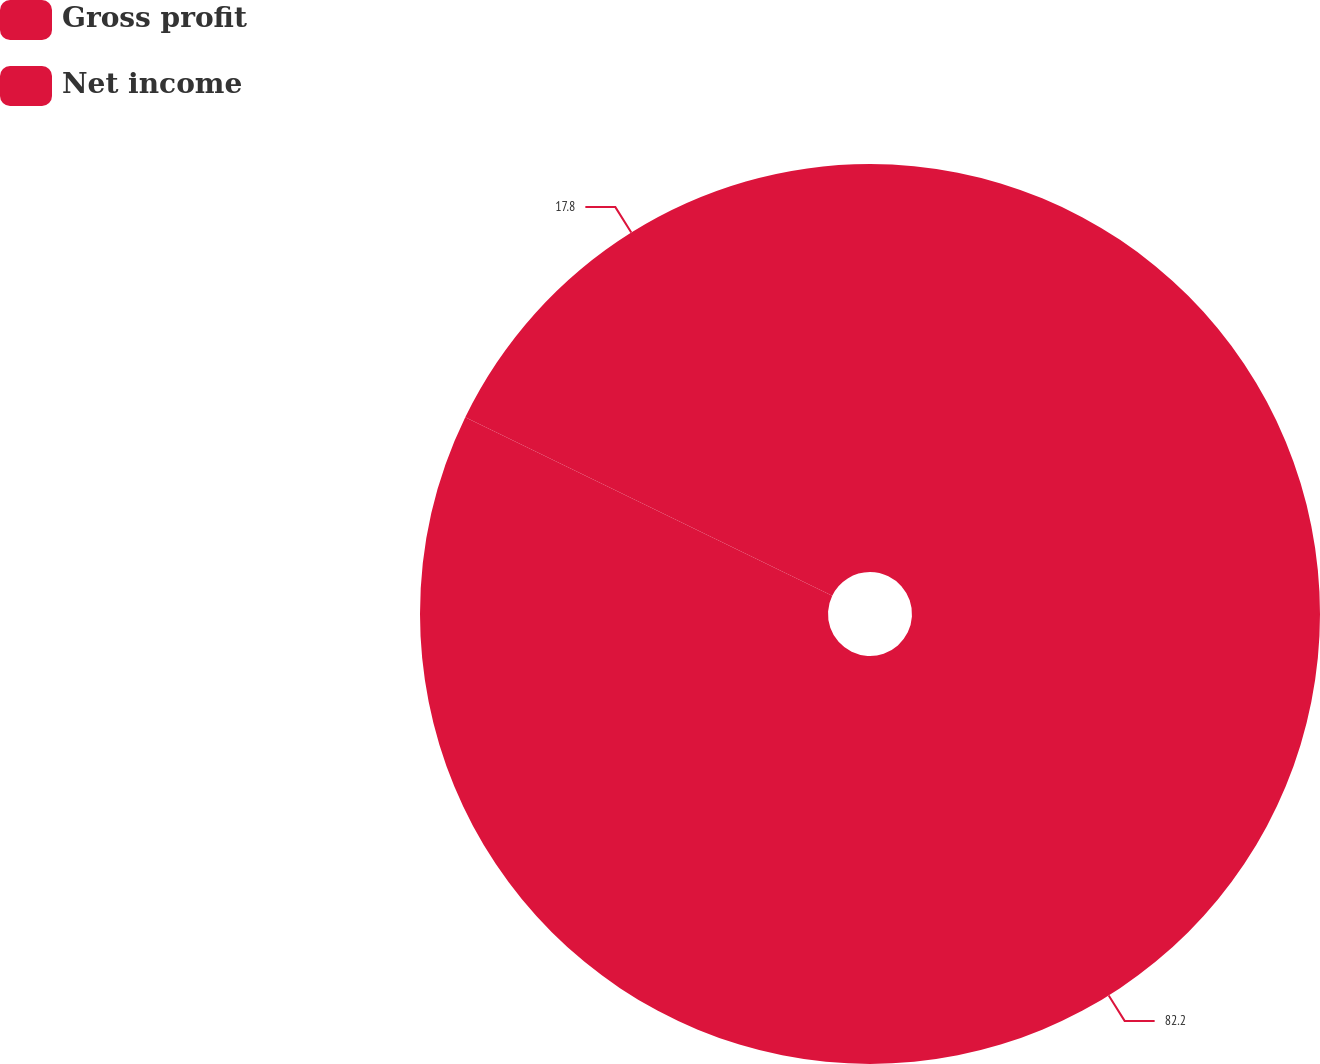<chart> <loc_0><loc_0><loc_500><loc_500><pie_chart><fcel>Gross profit<fcel>Net income<nl><fcel>82.2%<fcel>17.8%<nl></chart> 